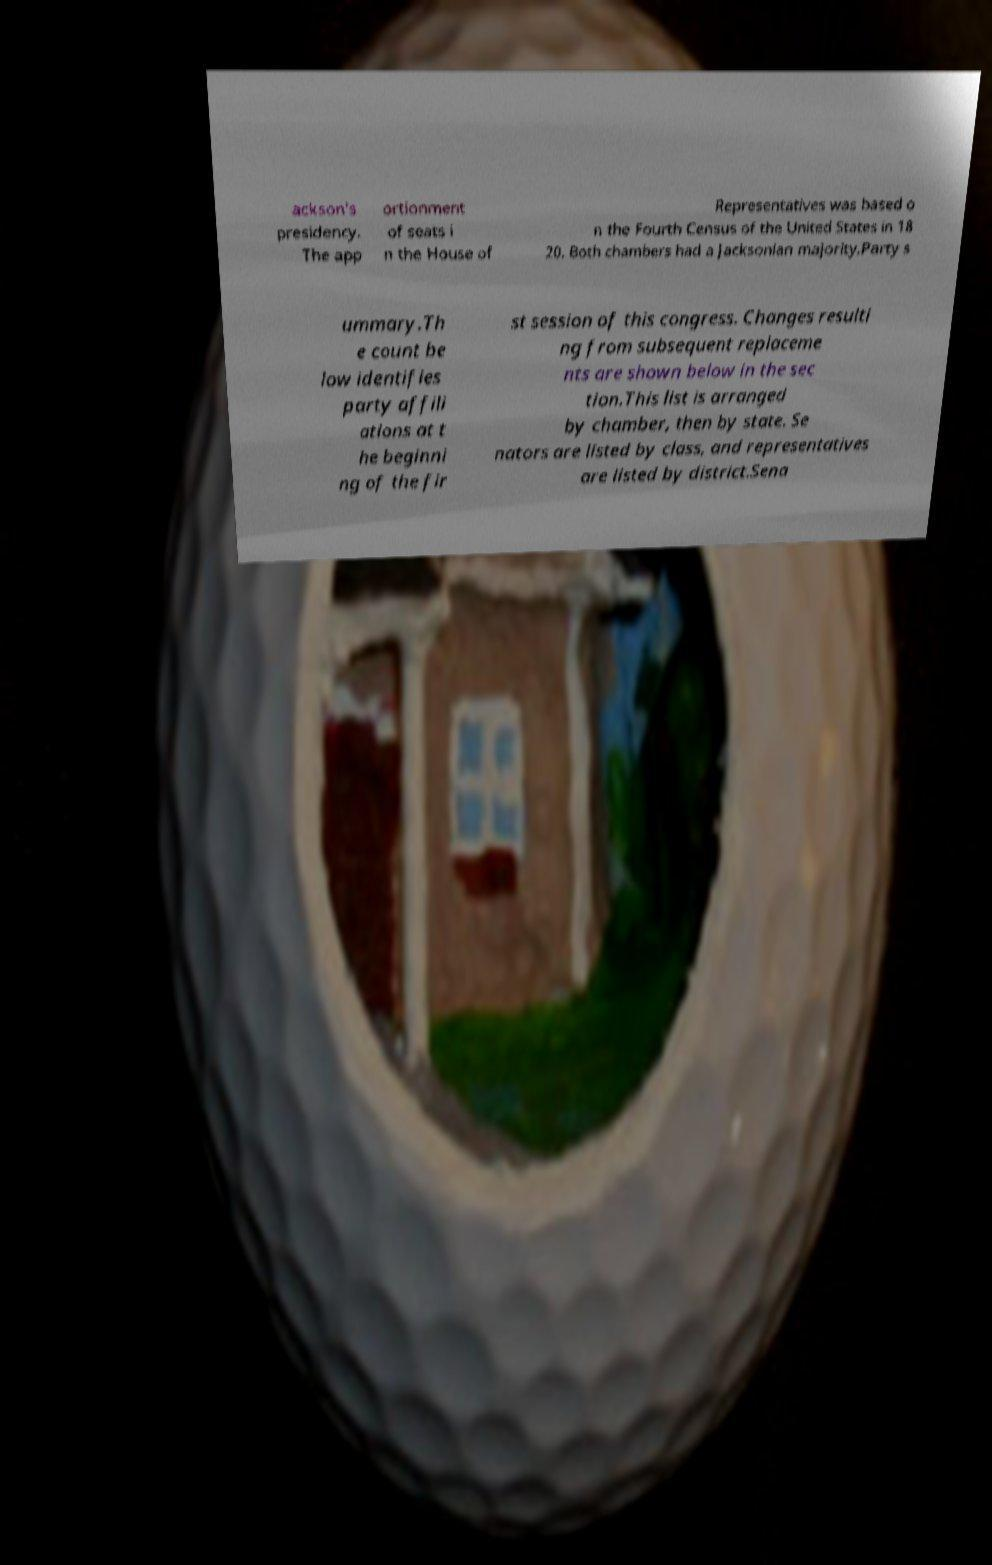Can you read and provide the text displayed in the image?This photo seems to have some interesting text. Can you extract and type it out for me? ackson's presidency. The app ortionment of seats i n the House of Representatives was based o n the Fourth Census of the United States in 18 20. Both chambers had a Jacksonian majority.Party s ummary.Th e count be low identifies party affili ations at t he beginni ng of the fir st session of this congress. Changes resulti ng from subsequent replaceme nts are shown below in the sec tion.This list is arranged by chamber, then by state. Se nators are listed by class, and representatives are listed by district.Sena 